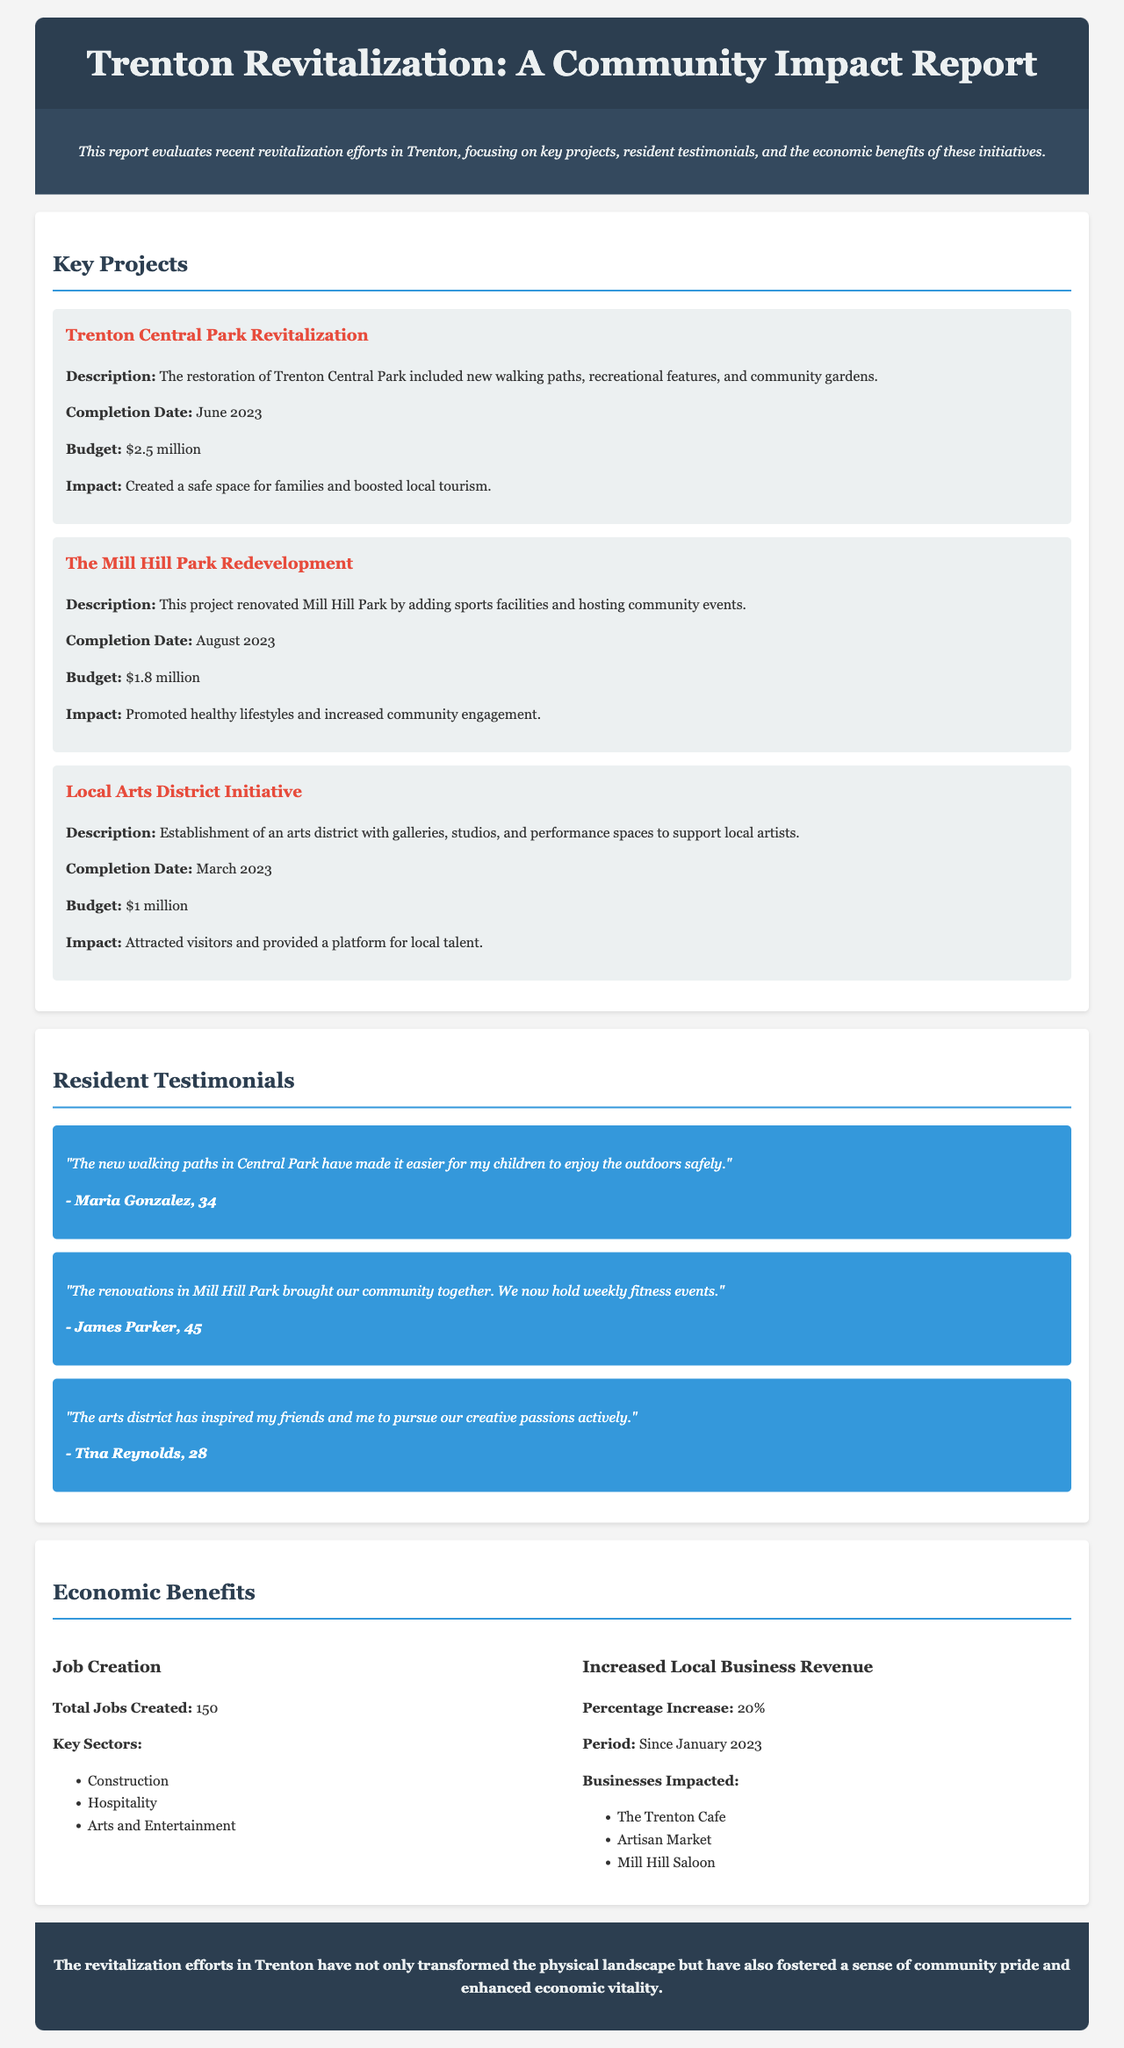What is the budget for the Trenton Central Park Revitalization? The budget for the Trenton Central Park Revitalization is mentioned in the document, which states it was $2.5 million.
Answer: $2.5 million When was the Local Arts District Initiative completed? The completion date for the Local Arts District Initiative is stated in the report as March 2023.
Answer: March 2023 How many total jobs were created through the revitalization efforts? The document lists the total number of jobs created as 150.
Answer: 150 What is the percentage increase in local business revenue since January 2023? The percentage increase in local business revenue is detailed in the Economic Benefits section, which indicates a 20% increase.
Answer: 20% Who is the resident that commented on the new walking paths in Central Park? The resident who commented on the new walking paths is Maria Gonzalez, as indicated in the Resident Testimonials section.
Answer: Maria Gonzalez What was a significant impact of the Mill Hill Park Redevelopment? The document mentions that the Mill Hill Park Redevelopment promoted healthy lifestyles and increased community engagement.
Answer: Promoted healthy lifestyles and increased community engagement Which organization operated the Trenton Cafe? The document indicates that The Trenton Cafe is one of the businesses impacted by the revitalization, reflecting community engagement.
Answer: The Trenton Cafe How many key sectors contributed to job creation? The report identifies three key sectors contributing to job creation, which are Construction, Hospitality, and Arts and Entertainment.
Answer: Three What is the conclusion of the report regarding the revitalization efforts? The conclusion mentions that the revitalization efforts have transformed the physical landscape and fostered community pride.
Answer: Transformed the physical landscape and fostered a sense of community pride 